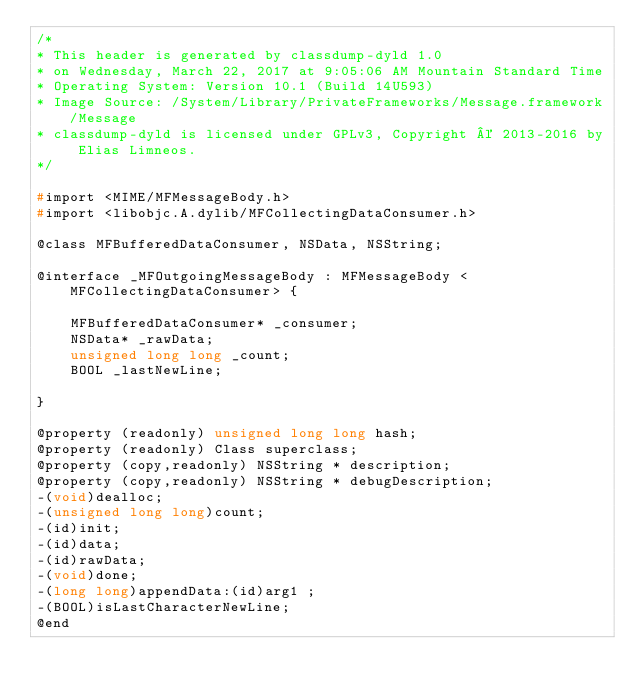Convert code to text. <code><loc_0><loc_0><loc_500><loc_500><_C_>/*
* This header is generated by classdump-dyld 1.0
* on Wednesday, March 22, 2017 at 9:05:06 AM Mountain Standard Time
* Operating System: Version 10.1 (Build 14U593)
* Image Source: /System/Library/PrivateFrameworks/Message.framework/Message
* classdump-dyld is licensed under GPLv3, Copyright © 2013-2016 by Elias Limneos.
*/

#import <MIME/MFMessageBody.h>
#import <libobjc.A.dylib/MFCollectingDataConsumer.h>

@class MFBufferedDataConsumer, NSData, NSString;

@interface _MFOutgoingMessageBody : MFMessageBody <MFCollectingDataConsumer> {

	MFBufferedDataConsumer* _consumer;
	NSData* _rawData;
	unsigned long long _count;
	BOOL _lastNewLine;

}

@property (readonly) unsigned long long hash; 
@property (readonly) Class superclass; 
@property (copy,readonly) NSString * description; 
@property (copy,readonly) NSString * debugDescription; 
-(void)dealloc;
-(unsigned long long)count;
-(id)init;
-(id)data;
-(id)rawData;
-(void)done;
-(long long)appendData:(id)arg1 ;
-(BOOL)isLastCharacterNewLine;
@end

</code> 